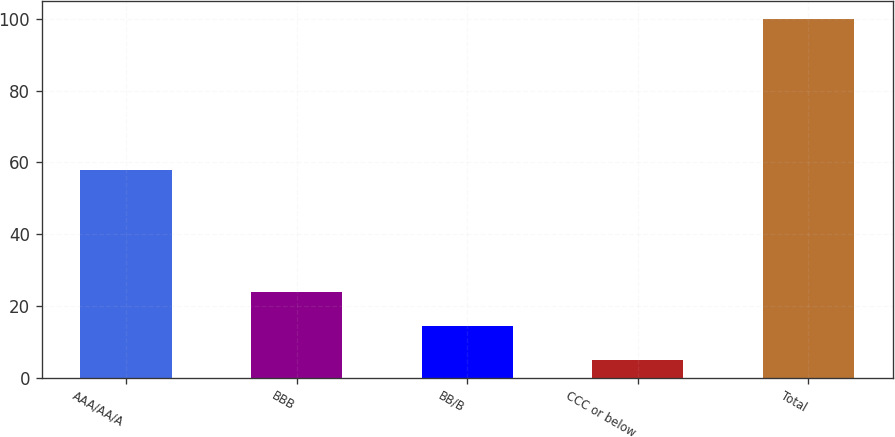Convert chart. <chart><loc_0><loc_0><loc_500><loc_500><bar_chart><fcel>AAA/AA/A<fcel>BBB<fcel>BB/B<fcel>CCC or below<fcel>Total<nl><fcel>58<fcel>24<fcel>14.5<fcel>5<fcel>100<nl></chart> 